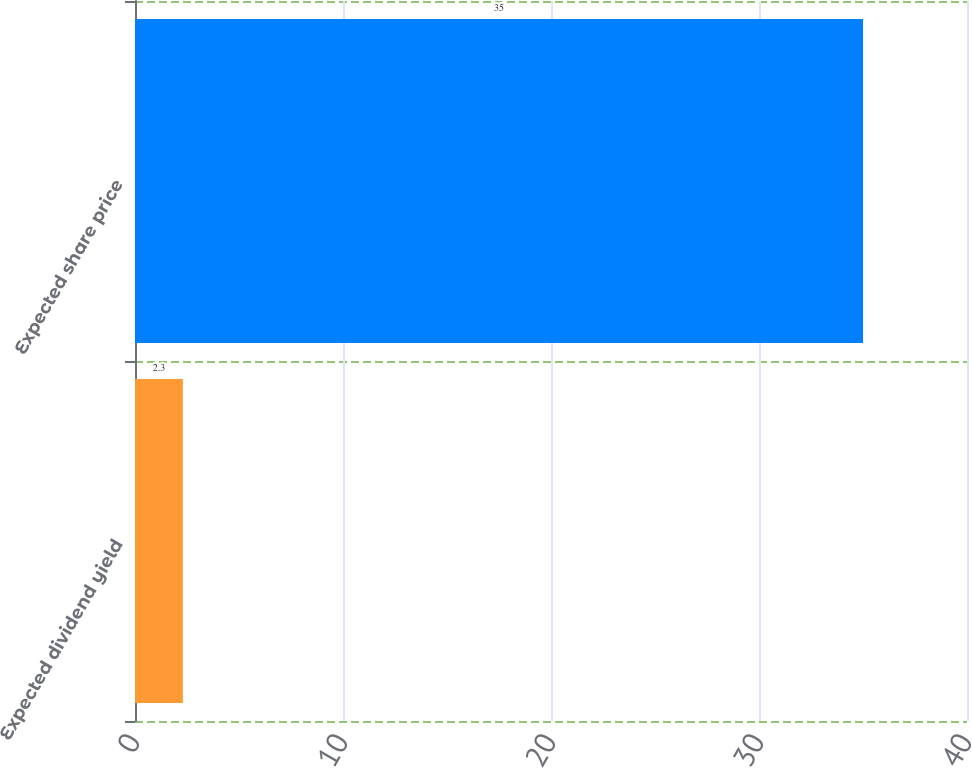<chart> <loc_0><loc_0><loc_500><loc_500><bar_chart><fcel>Expected dividend yield<fcel>Expected share price<nl><fcel>2.3<fcel>35<nl></chart> 